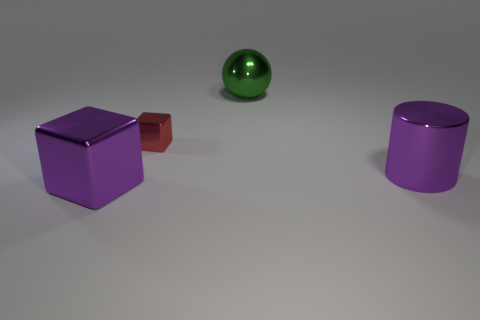Can you describe the different materials present among the objects in this image? Certainly! In the image, we observe objects made from two distinct materials. The purple cube and cylinder appear to exhibit a glossy, reflective surface, indicative of a material like plastic or polished metal. Conversely, the small brown cube has a matte finish, suggesting a porous or rough texture, like wood or stone. Lastly, the sphere seems to have a material finish that is similar to the glossy objects but is distinct in its smoothness and sheen, possibly glass or a polished gemstone. 